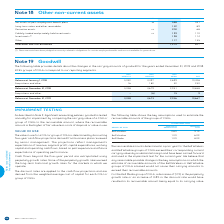According to Bce's financial document, What does BCE's groups of CGUS correspond to? According to the financial document, reporting segments. The relevant text states: "and 2018. BCE’s groups of CGUs correspond to our reporting segments...." Also, What is the balance for BCE at December 31, 2018? According to the financial document, 10,658. The relevant text states: "Balance at December 31, 2018 3,048 4,679 2,931 10,658..." Also, What is the balance for BCE at December 31, 2019? According to the financial document, 10,667. The relevant text states: "Balance at December 31, 2019 3,048 4,673 2,946 10,667..." Also, can you calculate: What is the change in the Balance comparing January 1, 2018 and December 31, 2019 for BCE? Based on the calculation: 10,667-10,428, the result is 239. This is based on the information: "Balance at December 31, 2019 3,048 4,673 2,946 10,667 Balance at January 1, 2018 3,032 4,497 2,899 10,428..." The key data points involved are: 10,428, 10,667. Also, can you calculate: What is the percentage change in the Balance comparing January 1, 2018 and December 31, 2019 for BCE? To answer this question, I need to perform calculations using the financial data. The calculation is: (10,667-10,428)/10,428, which equals 2.29 (percentage). This is based on the information: "Balance at December 31, 2019 3,048 4,673 2,946 10,667 Balance at January 1, 2018 3,032 4,497 2,899 10,428..." The key data points involved are: 10,428, 10,667. Also, can you calculate: What is the sum of acquisitions and other for Bell Wireless and Bell Wireline in 2018?  Based on the calculation: 182+16, the result is 198. This is based on the information: "Acquisitions and other 16 182 32 230 Acquisitions and other 16 182 32 230..." The key data points involved are: 16, 182. 